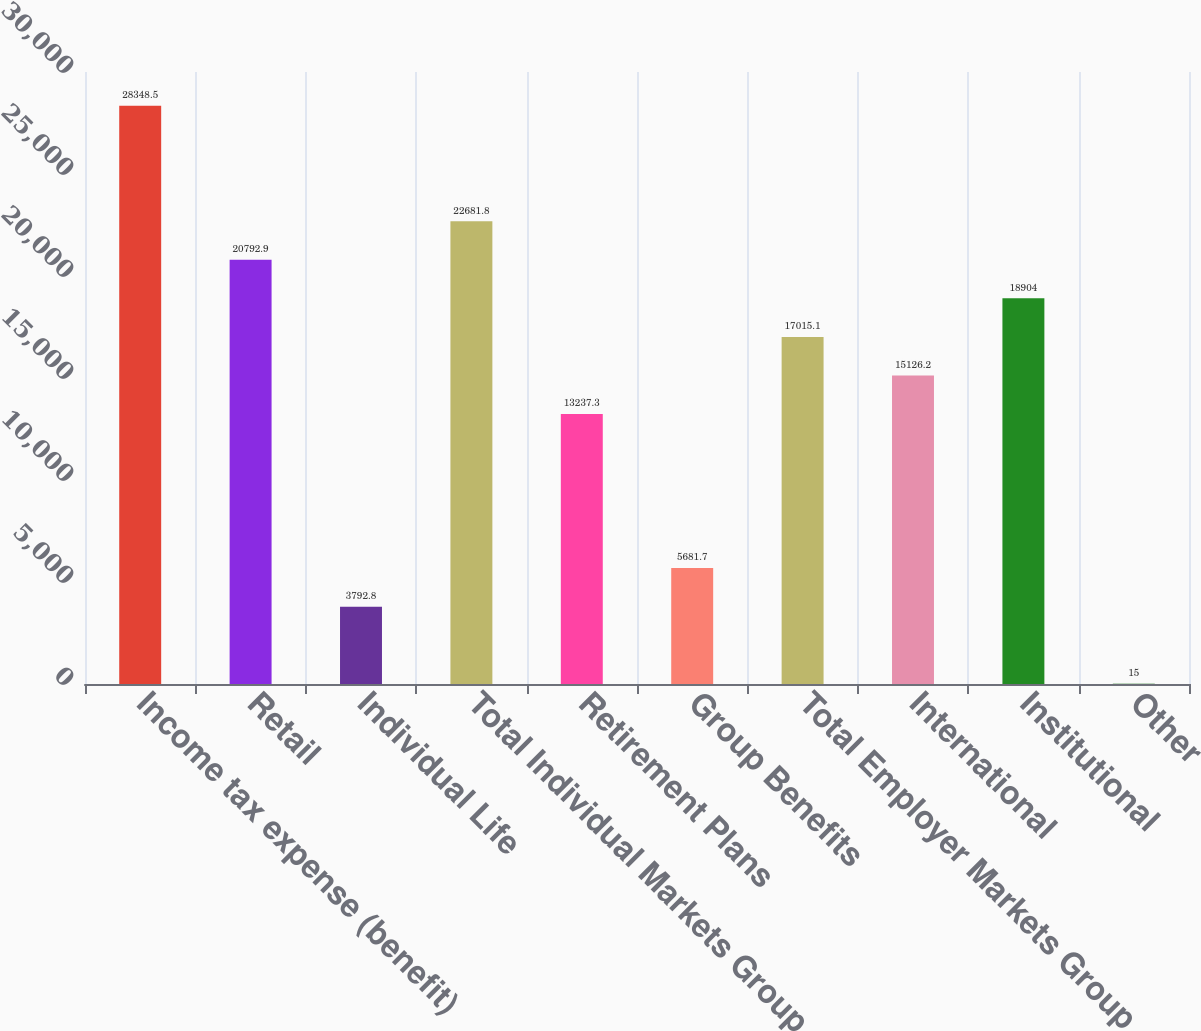<chart> <loc_0><loc_0><loc_500><loc_500><bar_chart><fcel>Income tax expense (benefit)<fcel>Retail<fcel>Individual Life<fcel>Total Individual Markets Group<fcel>Retirement Plans<fcel>Group Benefits<fcel>Total Employer Markets Group<fcel>International<fcel>Institutional<fcel>Other<nl><fcel>28348.5<fcel>20792.9<fcel>3792.8<fcel>22681.8<fcel>13237.3<fcel>5681.7<fcel>17015.1<fcel>15126.2<fcel>18904<fcel>15<nl></chart> 